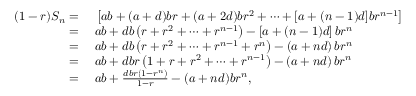<formula> <loc_0><loc_0><loc_500><loc_500>\begin{array} { r l } { ( 1 - r ) S _ { n } } & \left [ a b + ( a + d ) b r + ( a + 2 d ) b r ^ { 2 } + \cdots + [ a + ( n - 1 ) d ] b r ^ { n - 1 } \right ] } \\ { } & a b + d b \left ( r + r ^ { 2 } + \cdots + r ^ { n - 1 } \right ) - \left [ a + ( n - 1 ) d \right ] b r ^ { n } } \\ { } & a b + d b \left ( r + r ^ { 2 } + \cdots + r ^ { n - 1 } + r ^ { n } \right ) - \left ( a + n d \right ) b r ^ { n } } \\ { } & a b + d b r \left ( 1 + r + r ^ { 2 } + \cdots + r ^ { n - 1 } \right ) - \left ( a + n d \right ) b r ^ { n } } \\ { } & a b + { \frac { d b r ( 1 - r ^ { n } ) } { 1 - r } } - ( a + n d ) b r ^ { n } , } \end{array}</formula> 